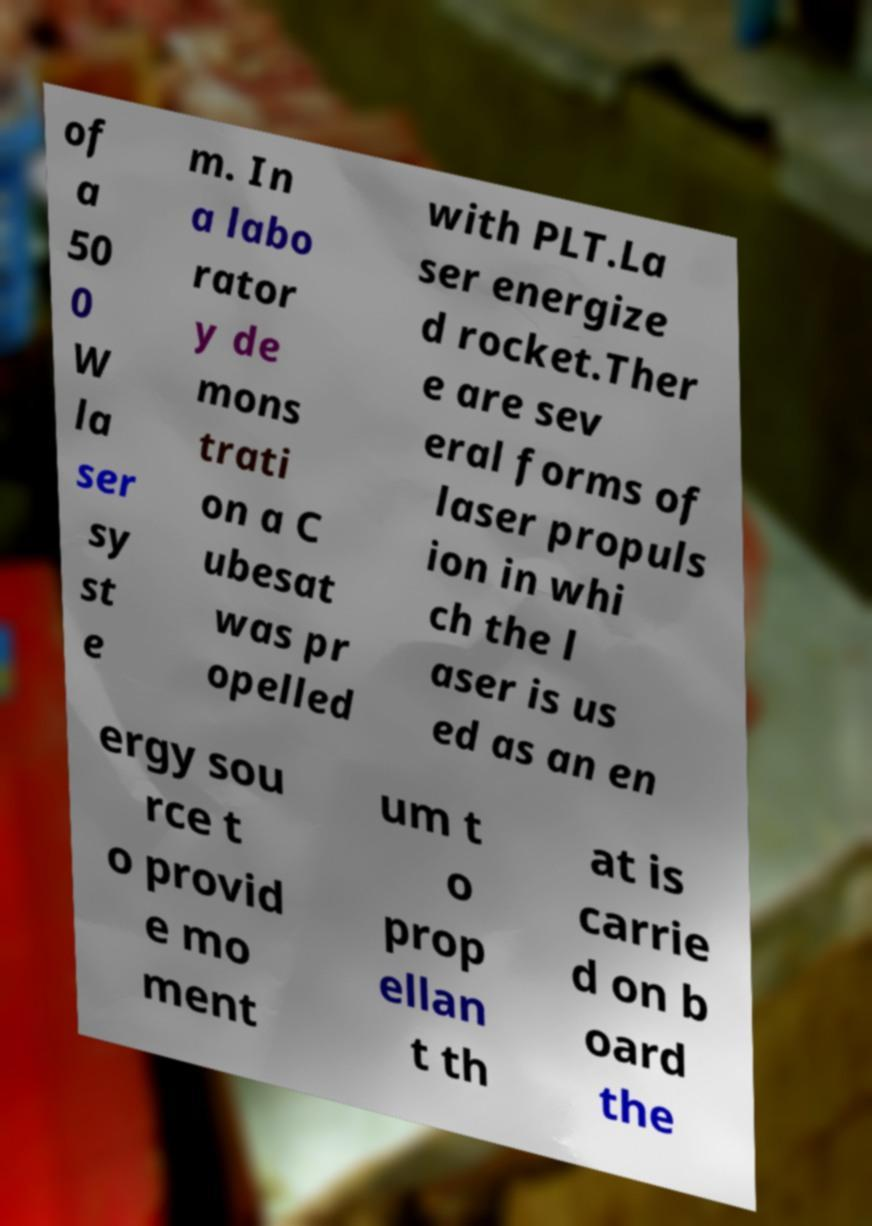What messages or text are displayed in this image? I need them in a readable, typed format. of a 50 0 W la ser sy st e m. In a labo rator y de mons trati on a C ubesat was pr opelled with PLT.La ser energize d rocket.Ther e are sev eral forms of laser propuls ion in whi ch the l aser is us ed as an en ergy sou rce t o provid e mo ment um t o prop ellan t th at is carrie d on b oard the 